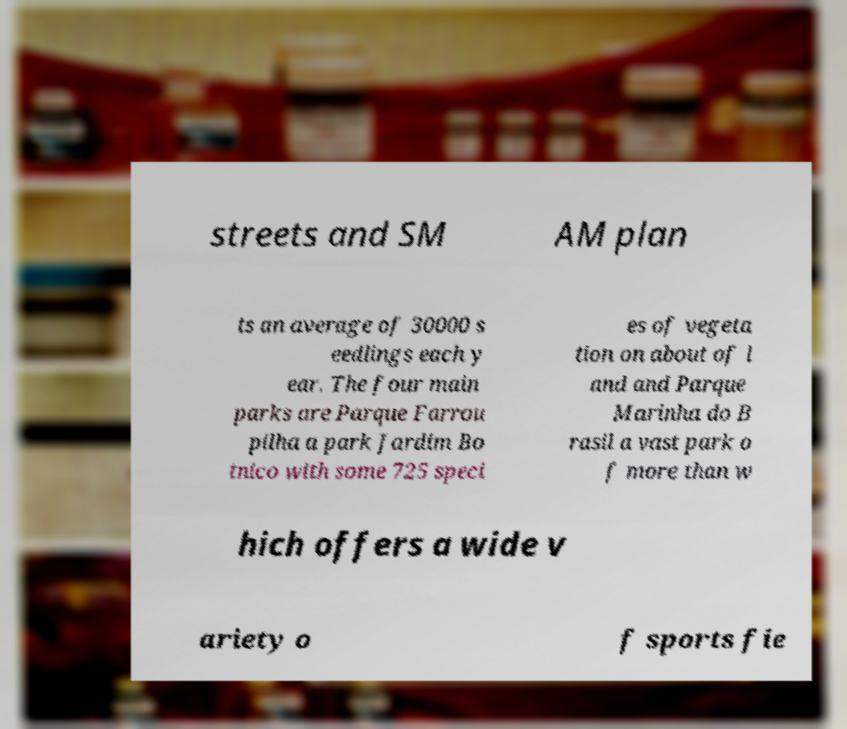Could you extract and type out the text from this image? streets and SM AM plan ts an average of 30000 s eedlings each y ear. The four main parks are Parque Farrou pilha a park Jardim Bo tnico with some 725 speci es of vegeta tion on about of l and and Parque Marinha do B rasil a vast park o f more than w hich offers a wide v ariety o f sports fie 